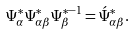<formula> <loc_0><loc_0><loc_500><loc_500>\Psi _ { \alpha } ^ { * } \Psi ^ { * } _ { \alpha \beta } \Psi _ { \beta } ^ { * - 1 } = \acute { \Psi } _ { \alpha \beta } ^ { * } .</formula> 